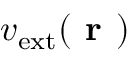<formula> <loc_0><loc_0><loc_500><loc_500>v _ { e x t } ( r )</formula> 